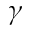<formula> <loc_0><loc_0><loc_500><loc_500>\gamma</formula> 